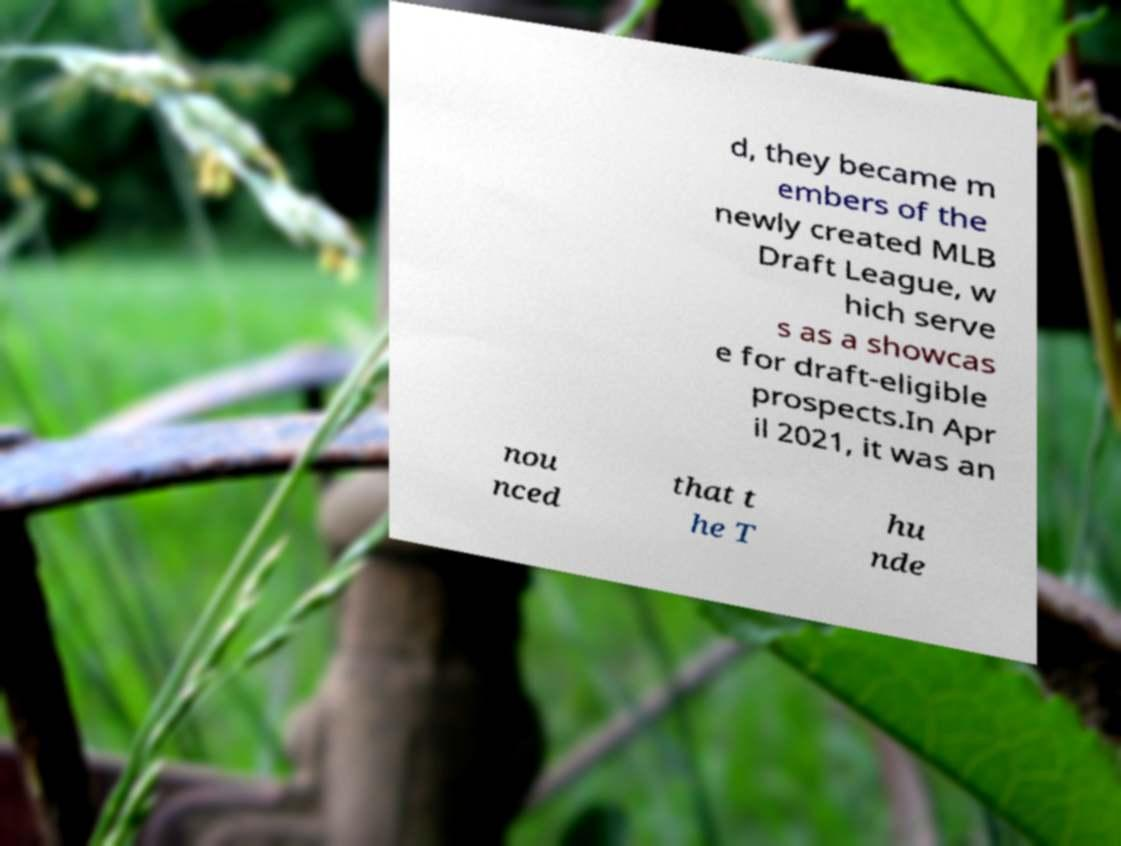Could you extract and type out the text from this image? d, they became m embers of the newly created MLB Draft League, w hich serve s as a showcas e for draft-eligible prospects.In Apr il 2021, it was an nou nced that t he T hu nde 